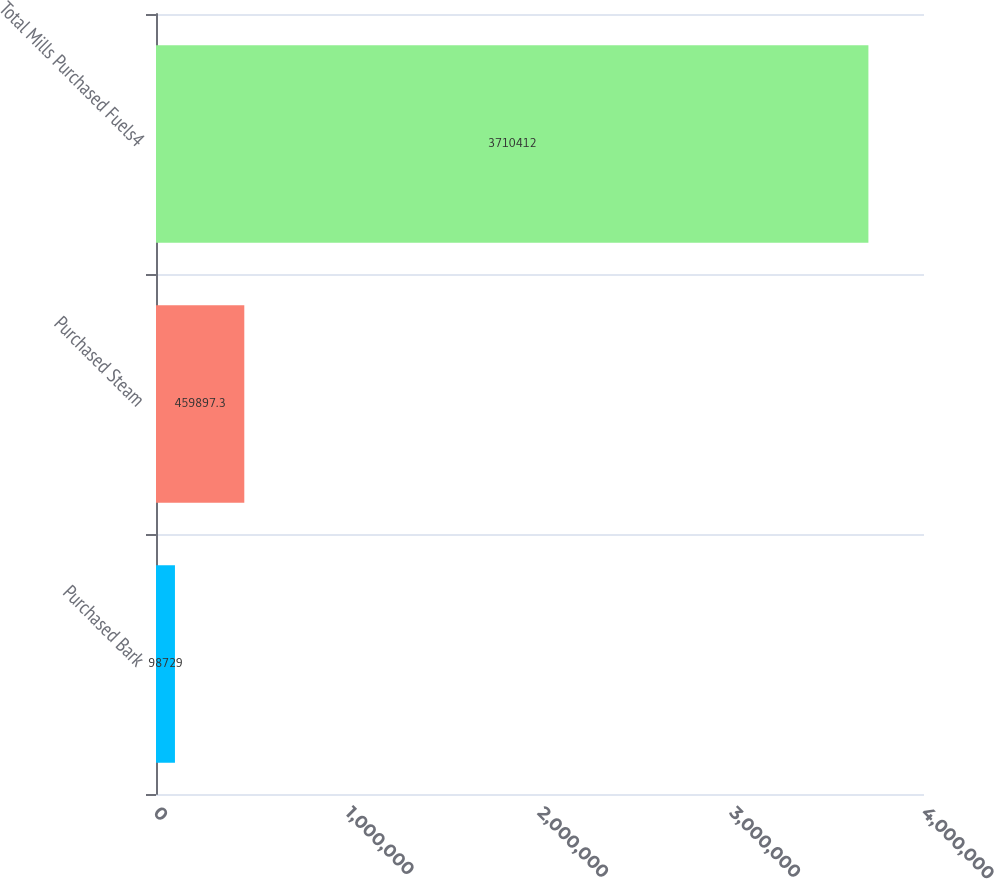<chart> <loc_0><loc_0><loc_500><loc_500><bar_chart><fcel>Purchased Bark<fcel>Purchased Steam<fcel>Total Mills Purchased Fuels4<nl><fcel>98729<fcel>459897<fcel>3.71041e+06<nl></chart> 